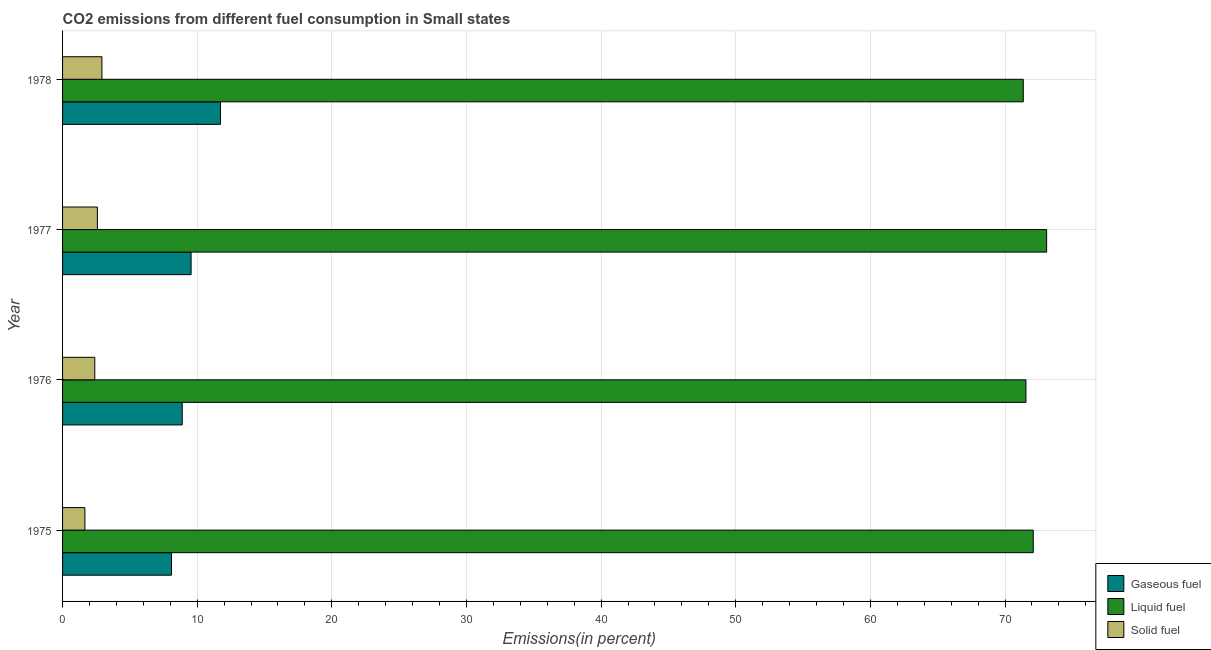How many groups of bars are there?
Provide a succinct answer. 4. In how many cases, is the number of bars for a given year not equal to the number of legend labels?
Your answer should be compact. 0. What is the percentage of gaseous fuel emission in 1978?
Make the answer very short. 11.73. Across all years, what is the maximum percentage of solid fuel emission?
Keep it short and to the point. 2.92. Across all years, what is the minimum percentage of gaseous fuel emission?
Your answer should be very brief. 8.09. In which year was the percentage of gaseous fuel emission maximum?
Offer a very short reply. 1978. In which year was the percentage of liquid fuel emission minimum?
Your answer should be compact. 1978. What is the total percentage of liquid fuel emission in the graph?
Keep it short and to the point. 288.09. What is the difference between the percentage of gaseous fuel emission in 1976 and that in 1977?
Offer a terse response. -0.66. What is the difference between the percentage of gaseous fuel emission in 1978 and the percentage of liquid fuel emission in 1977?
Keep it short and to the point. -61.36. What is the average percentage of gaseous fuel emission per year?
Your response must be concise. 9.56. In the year 1976, what is the difference between the percentage of solid fuel emission and percentage of liquid fuel emission?
Give a very brief answer. -69.16. In how many years, is the percentage of solid fuel emission greater than 58 %?
Your answer should be compact. 0. What is the ratio of the percentage of gaseous fuel emission in 1977 to that in 1978?
Keep it short and to the point. 0.81. What is the difference between the highest and the second highest percentage of liquid fuel emission?
Make the answer very short. 0.99. What is the difference between the highest and the lowest percentage of liquid fuel emission?
Give a very brief answer. 1.73. Is the sum of the percentage of liquid fuel emission in 1976 and 1978 greater than the maximum percentage of solid fuel emission across all years?
Offer a terse response. Yes. What does the 3rd bar from the top in 1975 represents?
Offer a very short reply. Gaseous fuel. What does the 2nd bar from the bottom in 1978 represents?
Offer a terse response. Liquid fuel. How many bars are there?
Your response must be concise. 12. Are all the bars in the graph horizontal?
Keep it short and to the point. Yes. How many years are there in the graph?
Ensure brevity in your answer.  4. What is the difference between two consecutive major ticks on the X-axis?
Give a very brief answer. 10. Does the graph contain any zero values?
Provide a succinct answer. No. Does the graph contain grids?
Provide a succinct answer. Yes. How are the legend labels stacked?
Make the answer very short. Vertical. What is the title of the graph?
Keep it short and to the point. CO2 emissions from different fuel consumption in Small states. What is the label or title of the X-axis?
Make the answer very short. Emissions(in percent). What is the Emissions(in percent) of Gaseous fuel in 1975?
Your answer should be very brief. 8.09. What is the Emissions(in percent) of Liquid fuel in 1975?
Provide a succinct answer. 72.1. What is the Emissions(in percent) of Solid fuel in 1975?
Your answer should be very brief. 1.66. What is the Emissions(in percent) of Gaseous fuel in 1976?
Make the answer very short. 8.89. What is the Emissions(in percent) of Liquid fuel in 1976?
Provide a succinct answer. 71.55. What is the Emissions(in percent) of Solid fuel in 1976?
Make the answer very short. 2.39. What is the Emissions(in percent) in Gaseous fuel in 1977?
Keep it short and to the point. 9.55. What is the Emissions(in percent) in Liquid fuel in 1977?
Offer a very short reply. 73.09. What is the Emissions(in percent) in Solid fuel in 1977?
Ensure brevity in your answer.  2.59. What is the Emissions(in percent) of Gaseous fuel in 1978?
Your answer should be very brief. 11.73. What is the Emissions(in percent) of Liquid fuel in 1978?
Your answer should be very brief. 71.36. What is the Emissions(in percent) of Solid fuel in 1978?
Offer a very short reply. 2.92. Across all years, what is the maximum Emissions(in percent) in Gaseous fuel?
Give a very brief answer. 11.73. Across all years, what is the maximum Emissions(in percent) of Liquid fuel?
Make the answer very short. 73.09. Across all years, what is the maximum Emissions(in percent) in Solid fuel?
Offer a terse response. 2.92. Across all years, what is the minimum Emissions(in percent) of Gaseous fuel?
Provide a succinct answer. 8.09. Across all years, what is the minimum Emissions(in percent) of Liquid fuel?
Your response must be concise. 71.36. Across all years, what is the minimum Emissions(in percent) of Solid fuel?
Keep it short and to the point. 1.66. What is the total Emissions(in percent) in Gaseous fuel in the graph?
Give a very brief answer. 38.25. What is the total Emissions(in percent) in Liquid fuel in the graph?
Make the answer very short. 288.09. What is the total Emissions(in percent) of Solid fuel in the graph?
Your answer should be compact. 9.56. What is the difference between the Emissions(in percent) in Gaseous fuel in 1975 and that in 1976?
Your answer should be very brief. -0.8. What is the difference between the Emissions(in percent) in Liquid fuel in 1975 and that in 1976?
Your answer should be compact. 0.54. What is the difference between the Emissions(in percent) in Solid fuel in 1975 and that in 1976?
Provide a succinct answer. -0.73. What is the difference between the Emissions(in percent) of Gaseous fuel in 1975 and that in 1977?
Your answer should be very brief. -1.46. What is the difference between the Emissions(in percent) in Liquid fuel in 1975 and that in 1977?
Provide a short and direct response. -0.99. What is the difference between the Emissions(in percent) in Solid fuel in 1975 and that in 1977?
Give a very brief answer. -0.93. What is the difference between the Emissions(in percent) of Gaseous fuel in 1975 and that in 1978?
Your answer should be very brief. -3.64. What is the difference between the Emissions(in percent) of Liquid fuel in 1975 and that in 1978?
Your answer should be very brief. 0.74. What is the difference between the Emissions(in percent) of Solid fuel in 1975 and that in 1978?
Give a very brief answer. -1.26. What is the difference between the Emissions(in percent) of Gaseous fuel in 1976 and that in 1977?
Your answer should be compact. -0.66. What is the difference between the Emissions(in percent) in Liquid fuel in 1976 and that in 1977?
Provide a succinct answer. -1.54. What is the difference between the Emissions(in percent) in Solid fuel in 1976 and that in 1977?
Ensure brevity in your answer.  -0.19. What is the difference between the Emissions(in percent) in Gaseous fuel in 1976 and that in 1978?
Provide a succinct answer. -2.84. What is the difference between the Emissions(in percent) in Liquid fuel in 1976 and that in 1978?
Your answer should be compact. 0.2. What is the difference between the Emissions(in percent) of Solid fuel in 1976 and that in 1978?
Your answer should be compact. -0.53. What is the difference between the Emissions(in percent) in Gaseous fuel in 1977 and that in 1978?
Provide a short and direct response. -2.18. What is the difference between the Emissions(in percent) in Liquid fuel in 1977 and that in 1978?
Your answer should be compact. 1.73. What is the difference between the Emissions(in percent) in Solid fuel in 1977 and that in 1978?
Provide a short and direct response. -0.34. What is the difference between the Emissions(in percent) of Gaseous fuel in 1975 and the Emissions(in percent) of Liquid fuel in 1976?
Keep it short and to the point. -63.46. What is the difference between the Emissions(in percent) of Gaseous fuel in 1975 and the Emissions(in percent) of Solid fuel in 1976?
Your answer should be very brief. 5.7. What is the difference between the Emissions(in percent) in Liquid fuel in 1975 and the Emissions(in percent) in Solid fuel in 1976?
Provide a succinct answer. 69.7. What is the difference between the Emissions(in percent) in Gaseous fuel in 1975 and the Emissions(in percent) in Liquid fuel in 1977?
Provide a short and direct response. -65. What is the difference between the Emissions(in percent) of Gaseous fuel in 1975 and the Emissions(in percent) of Solid fuel in 1977?
Your response must be concise. 5.5. What is the difference between the Emissions(in percent) in Liquid fuel in 1975 and the Emissions(in percent) in Solid fuel in 1977?
Provide a short and direct response. 69.51. What is the difference between the Emissions(in percent) in Gaseous fuel in 1975 and the Emissions(in percent) in Liquid fuel in 1978?
Ensure brevity in your answer.  -63.27. What is the difference between the Emissions(in percent) in Gaseous fuel in 1975 and the Emissions(in percent) in Solid fuel in 1978?
Offer a very short reply. 5.17. What is the difference between the Emissions(in percent) of Liquid fuel in 1975 and the Emissions(in percent) of Solid fuel in 1978?
Offer a terse response. 69.17. What is the difference between the Emissions(in percent) of Gaseous fuel in 1976 and the Emissions(in percent) of Liquid fuel in 1977?
Offer a terse response. -64.2. What is the difference between the Emissions(in percent) of Gaseous fuel in 1976 and the Emissions(in percent) of Solid fuel in 1977?
Offer a terse response. 6.3. What is the difference between the Emissions(in percent) of Liquid fuel in 1976 and the Emissions(in percent) of Solid fuel in 1977?
Provide a succinct answer. 68.97. What is the difference between the Emissions(in percent) in Gaseous fuel in 1976 and the Emissions(in percent) in Liquid fuel in 1978?
Offer a very short reply. -62.47. What is the difference between the Emissions(in percent) in Gaseous fuel in 1976 and the Emissions(in percent) in Solid fuel in 1978?
Your answer should be very brief. 5.96. What is the difference between the Emissions(in percent) of Liquid fuel in 1976 and the Emissions(in percent) of Solid fuel in 1978?
Provide a succinct answer. 68.63. What is the difference between the Emissions(in percent) in Gaseous fuel in 1977 and the Emissions(in percent) in Liquid fuel in 1978?
Your answer should be very brief. -61.81. What is the difference between the Emissions(in percent) in Gaseous fuel in 1977 and the Emissions(in percent) in Solid fuel in 1978?
Provide a short and direct response. 6.62. What is the difference between the Emissions(in percent) of Liquid fuel in 1977 and the Emissions(in percent) of Solid fuel in 1978?
Your response must be concise. 70.17. What is the average Emissions(in percent) in Gaseous fuel per year?
Your response must be concise. 9.56. What is the average Emissions(in percent) in Liquid fuel per year?
Your answer should be compact. 72.02. What is the average Emissions(in percent) in Solid fuel per year?
Offer a terse response. 2.39. In the year 1975, what is the difference between the Emissions(in percent) in Gaseous fuel and Emissions(in percent) in Liquid fuel?
Provide a short and direct response. -64.01. In the year 1975, what is the difference between the Emissions(in percent) in Gaseous fuel and Emissions(in percent) in Solid fuel?
Your response must be concise. 6.43. In the year 1975, what is the difference between the Emissions(in percent) of Liquid fuel and Emissions(in percent) of Solid fuel?
Ensure brevity in your answer.  70.44. In the year 1976, what is the difference between the Emissions(in percent) in Gaseous fuel and Emissions(in percent) in Liquid fuel?
Provide a succinct answer. -62.67. In the year 1976, what is the difference between the Emissions(in percent) of Gaseous fuel and Emissions(in percent) of Solid fuel?
Keep it short and to the point. 6.49. In the year 1976, what is the difference between the Emissions(in percent) in Liquid fuel and Emissions(in percent) in Solid fuel?
Your answer should be compact. 69.16. In the year 1977, what is the difference between the Emissions(in percent) of Gaseous fuel and Emissions(in percent) of Liquid fuel?
Provide a succinct answer. -63.54. In the year 1977, what is the difference between the Emissions(in percent) in Gaseous fuel and Emissions(in percent) in Solid fuel?
Offer a very short reply. 6.96. In the year 1977, what is the difference between the Emissions(in percent) in Liquid fuel and Emissions(in percent) in Solid fuel?
Make the answer very short. 70.5. In the year 1978, what is the difference between the Emissions(in percent) in Gaseous fuel and Emissions(in percent) in Liquid fuel?
Offer a terse response. -59.63. In the year 1978, what is the difference between the Emissions(in percent) of Gaseous fuel and Emissions(in percent) of Solid fuel?
Give a very brief answer. 8.81. In the year 1978, what is the difference between the Emissions(in percent) of Liquid fuel and Emissions(in percent) of Solid fuel?
Your answer should be compact. 68.43. What is the ratio of the Emissions(in percent) in Gaseous fuel in 1975 to that in 1976?
Provide a succinct answer. 0.91. What is the ratio of the Emissions(in percent) of Liquid fuel in 1975 to that in 1976?
Give a very brief answer. 1.01. What is the ratio of the Emissions(in percent) of Solid fuel in 1975 to that in 1976?
Your answer should be very brief. 0.69. What is the ratio of the Emissions(in percent) in Gaseous fuel in 1975 to that in 1977?
Your answer should be compact. 0.85. What is the ratio of the Emissions(in percent) of Liquid fuel in 1975 to that in 1977?
Your answer should be very brief. 0.99. What is the ratio of the Emissions(in percent) of Solid fuel in 1975 to that in 1977?
Provide a succinct answer. 0.64. What is the ratio of the Emissions(in percent) of Gaseous fuel in 1975 to that in 1978?
Offer a terse response. 0.69. What is the ratio of the Emissions(in percent) of Liquid fuel in 1975 to that in 1978?
Provide a succinct answer. 1.01. What is the ratio of the Emissions(in percent) in Solid fuel in 1975 to that in 1978?
Your answer should be compact. 0.57. What is the ratio of the Emissions(in percent) in Gaseous fuel in 1976 to that in 1977?
Your answer should be very brief. 0.93. What is the ratio of the Emissions(in percent) in Liquid fuel in 1976 to that in 1977?
Provide a succinct answer. 0.98. What is the ratio of the Emissions(in percent) of Solid fuel in 1976 to that in 1977?
Give a very brief answer. 0.93. What is the ratio of the Emissions(in percent) in Gaseous fuel in 1976 to that in 1978?
Make the answer very short. 0.76. What is the ratio of the Emissions(in percent) of Liquid fuel in 1976 to that in 1978?
Give a very brief answer. 1. What is the ratio of the Emissions(in percent) of Solid fuel in 1976 to that in 1978?
Make the answer very short. 0.82. What is the ratio of the Emissions(in percent) of Gaseous fuel in 1977 to that in 1978?
Offer a terse response. 0.81. What is the ratio of the Emissions(in percent) in Liquid fuel in 1977 to that in 1978?
Keep it short and to the point. 1.02. What is the ratio of the Emissions(in percent) in Solid fuel in 1977 to that in 1978?
Provide a short and direct response. 0.89. What is the difference between the highest and the second highest Emissions(in percent) of Gaseous fuel?
Keep it short and to the point. 2.18. What is the difference between the highest and the second highest Emissions(in percent) of Liquid fuel?
Keep it short and to the point. 0.99. What is the difference between the highest and the second highest Emissions(in percent) in Solid fuel?
Give a very brief answer. 0.34. What is the difference between the highest and the lowest Emissions(in percent) of Gaseous fuel?
Your answer should be very brief. 3.64. What is the difference between the highest and the lowest Emissions(in percent) of Liquid fuel?
Provide a short and direct response. 1.73. What is the difference between the highest and the lowest Emissions(in percent) of Solid fuel?
Ensure brevity in your answer.  1.26. 